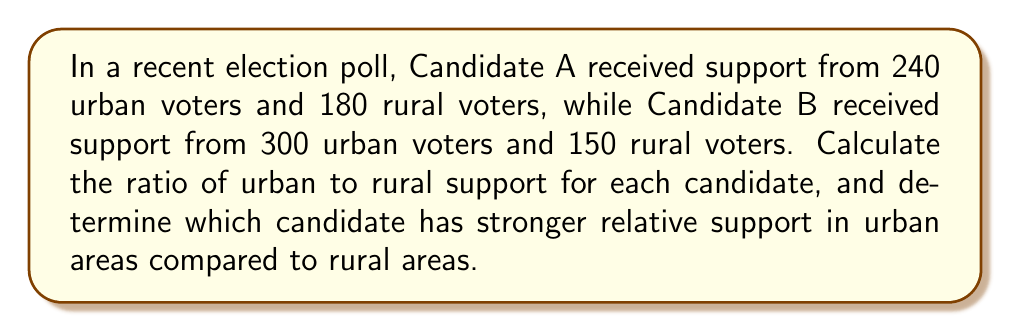Solve this math problem. Let's approach this step-by-step using ratios to compare the candidates' support:

1) For Candidate A:
   Urban support: 240
   Rural support: 180
   Ratio = $\frac{240}{180} = \frac{4}{3}$ (simplified)

2) For Candidate B:
   Urban support: 300
   Rural support: 150
   Ratio = $\frac{300}{150} = \frac{2}{1} = 2$ (simplified)

3) To compare these ratios, we can convert them to decimals:
   Candidate A: $\frac{4}{3} \approx 1.33$
   Candidate B: $2 = 2.00$

4) Since 2.00 > 1.33, Candidate B has a higher ratio of urban to rural support.

This analysis, based on concrete polling data rather than speculation, indicates that Candidate B has stronger relative support in urban areas compared to rural areas.
Answer: Candidate B (urban:rural ratio of 2:1 vs 4:3 for Candidate A) 